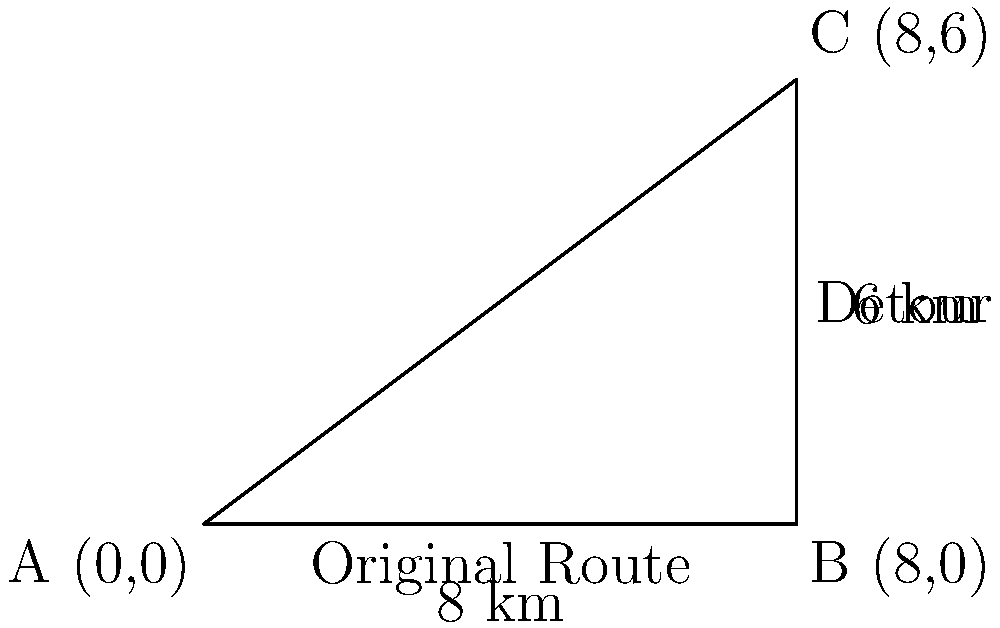Due to road maintenance, a small business owner must take a detour that forms a right-angled triangle with the original route. The detour goes 8 km east and then 6 km north to reach the destination. Using trigonometric functions, calculate how much additional distance the business owner must travel compared to the original direct route. Let's approach this step-by-step:

1) The detour forms a right-angled triangle. We know two sides:
   - The base (east direction) is 8 km
   - The height (north direction) is 6 km

2) To find the length of the original route (hypotenuse), we can use the Pythagorean theorem:

   $$c^2 = a^2 + b^2$$
   $$c^2 = 8^2 + 6^2 = 64 + 36 = 100$$
   $$c = \sqrt{100} = 10\text{ km}$$

3) The length of the detour is the sum of the two known sides:
   $$\text{Detour length} = 8 + 6 = 14\text{ km}$$

4) The additional distance is the difference between the detour and the original route:
   $$\text{Additional distance} = 14 - 10 = 4\text{ km}$$

Thus, the business owner must travel an additional 4 km due to the detour.
Answer: 4 km 